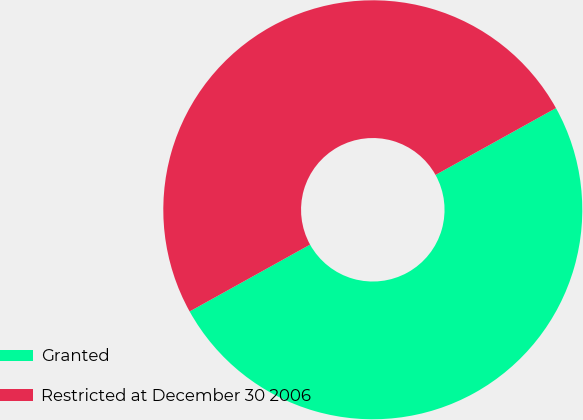<chart> <loc_0><loc_0><loc_500><loc_500><pie_chart><fcel>Granted<fcel>Restricted at December 30 2006<nl><fcel>50.0%<fcel>50.0%<nl></chart> 